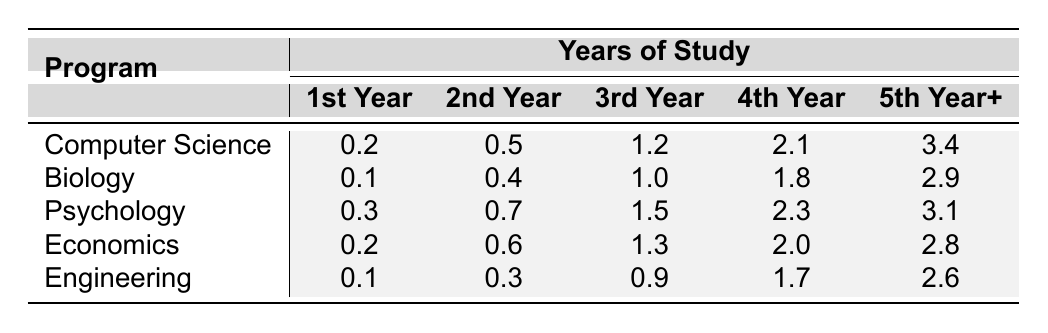What is the publication rate for Computer Science students in their 4th year? The table indicates that the publication rate for Computer Science students in their 4th year is 2.1.
Answer: 2.1 What is the highest publication rate among the 5th Year+ students, and which program has it? The highest publication rate among 5th Year+ students is 3.4, which is for the Computer Science program.
Answer: 3.4 (Computer Science) How much higher is the publication rate for 3rd Year Psychology students compared to 1st Year Psychology students? The publication rate for 3rd Year Psychology students is 1.5, while for 1st Year students, it is 0.3. The difference is 1.5 - 0.3 = 1.2.
Answer: 1.2 Is the publication rate for 2nd Year Engineering students greater than that of 2nd Year Biology students? The publication rate for 2nd Year Engineering students is 0.3, while for 2nd Year Biology students, it is 0.4. Therefore, 0.3 is not greater than 0.4, making the statement false.
Answer: No What is the average publication rate for 4th Year students across all programs? To find the average, add the 4th Year values: 2.1 (CS) + 1.8 (Bio) + 2.3 (Psych) + 2.0 (Econ) + 1.7 (Eng) = 10.9. Then divide by the number of programs (5): 10.9 / 5 = 2.18.
Answer: 2.18 Which doctoral program has the lowest publication rate in the 1st Year? The publication rates for 1st Year students are 0.2 (CS), 0.1 (Bio), 0.3 (Psych), 0.2 (Econ), and 0.1 (Eng). The lowest is 0.1 for both Biology and Engineering.
Answer: Biology and Engineering What is the difference between the publication rates of 5th Year+ students in Psychology and Economics programs? The publication rate for 5th Year+ Psychology students is 3.1, and for Economics, it is 2.8. The difference is 3.1 - 2.8 = 0.3.
Answer: 0.3 If you combine the publication rates of 2nd Year students across all programs, what is the total? Adding the 2nd Year rates: 0.5 (CS) + 0.4 (Bio) + 0.7 (Psych) + 0.6 (Econ) + 0.3 (Eng) gives a total of 2.5.
Answer: 2.5 In which year do Psychology students have a publication rate closest to that of Engineering students? Looking at the rates, Engineering students in the 3rd Year have a publication rate of 0.9, while Psychology students have 1.5. The closest year is the 3rd Year with a difference of 0.6.
Answer: 3rd Year How does the publication rate for 2nd Year students in Computer Science compare to that of 3rd Year students in Engineering? The 2nd Year publication rate in Computer Science is 0.5, and the 3rd Year publication rate in Engineering is 0.9. Thus, 0.5 is less than 0.9.
Answer: Less 